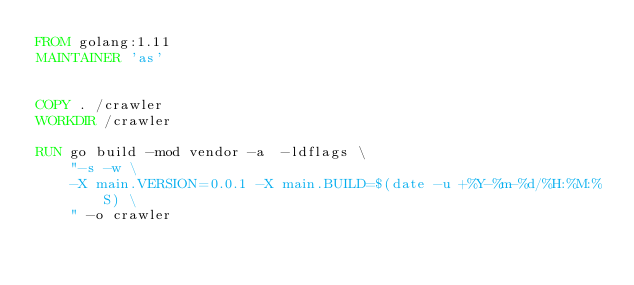<code> <loc_0><loc_0><loc_500><loc_500><_Dockerfile_>FROM golang:1.11
MAINTAINER 'as'


COPY . /crawler
WORKDIR /crawler

RUN go build -mod vendor -a  -ldflags \
    "-s -w \
    -X main.VERSION=0.0.1 -X main.BUILD=$(date -u +%Y-%m-%d/%H:%M:%S) \
    " -o crawler
</code> 